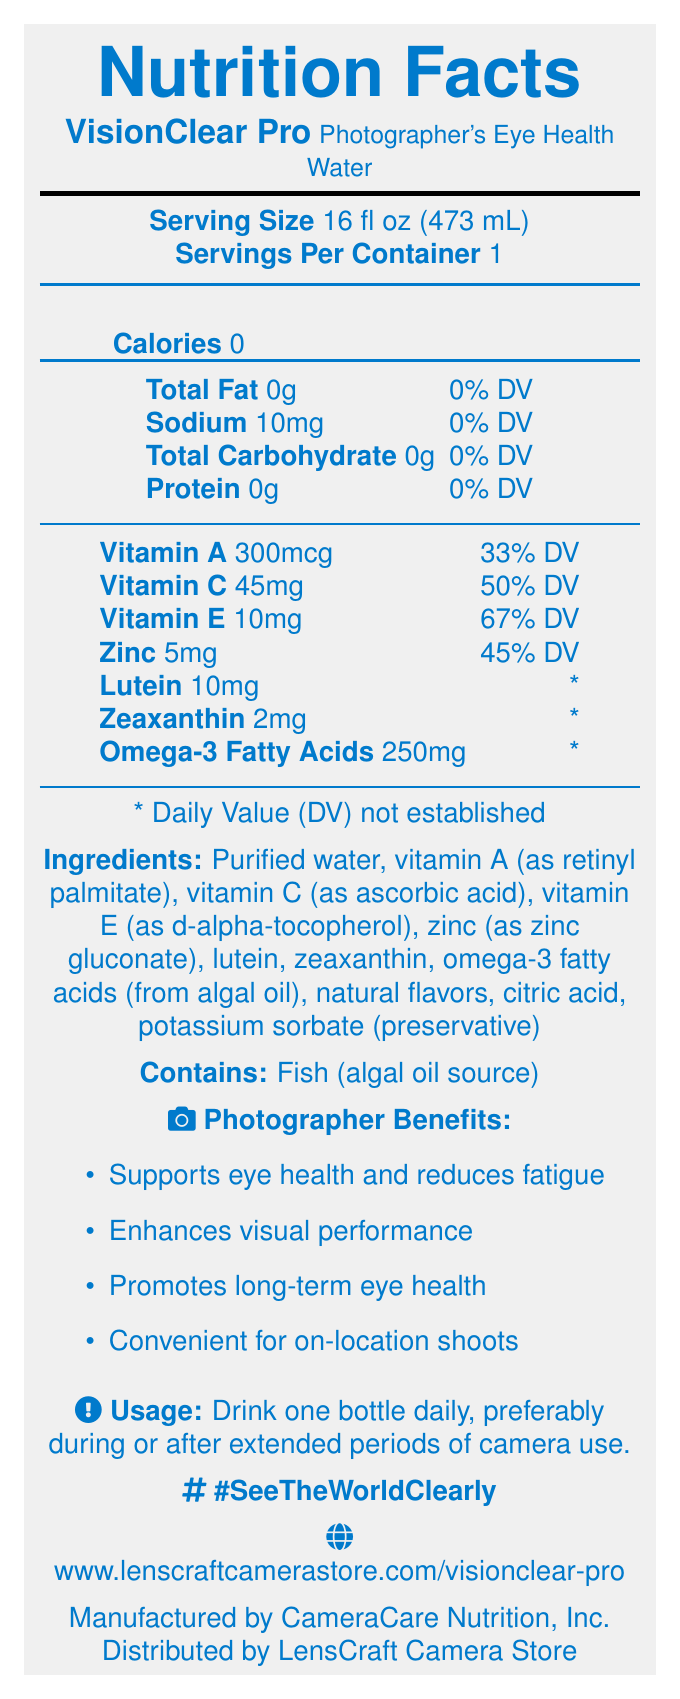what is the serving size for VisionClear Pro? The serving size is listed as "16 fl oz (473 mL)" in the document.
Answer: 16 fl oz (473 mL) how many servings per container are there? The document states there is 1 serving per container.
Answer: 1 how many calories are in one serving of VisionClear Pro? The document lists 0 calories under the nutrition facts.
Answer: 0 what percentage of the daily value does Vitamin A provide? The document states that Vitamin A provides 33% of the daily value.
Answer: 33% which manufacturer produces VisionClear Pro? The manufacturer listed is CameraCare Nutrition, Inc.
Answer: CameraCare Nutrition, Inc. Which of the following nutrients is not listed in the Nutrition Facts? A. Vitamin B12 B. Zinc C. Vitamin E D. Lutein Vitamin B12 is not listed in the Nutrition Facts, whereas Zinc, Vitamin E, and Lutein are included.
Answer: A What is the main ingredient in VisionClear Pro? A. Purified water B. Vitamin A C. Omega-3 Fatty Acids D. Citric Acid The first and primary ingredient listed is purified water.
Answer: A True or False: VisionClear Pro contains an ingredient derived from fish. The allergen information specifies that the product contains fish (algal oil source).
Answer: True Summarize the main idea of the VisionClear Pro document. The summary includes details on the product’s purpose (supporting eye health for photographers), key nutrients, manufacturer and distributor, and its health benefits.
Answer: VisionClear Pro is a vitamin-enriched bottled water designed to support eye health for photographers. It contains essential nutrients like Vitamin A, C, and E, as well as lutein, zeaxanthin, and omega-3 fatty acids. The drink is calorie-free and aims to reduce eye strain and enhance visual performance. It is manufactured by CameraCare Nutrition, Inc. and distributed by LensCraft Camera Store. how much sodium is in a serving of VisionClear Pro? The document indicates that there are 10mg of sodium per serving.
Answer: 10mg how should VisionClear Pro be stored after opening? The storage instructions specify to refrigerate after opening.
Answer: Refrigerate after opening what is the campaign hashtag for VisionClear Pro? The document lists the campaign hashtag as #SeeTheWorldClearly.
Answer: #SeeTheWorldClearly what benefits does VisionClear Pro claim to provide for photographers? The document claims it supports eye health, reduces fatigue, enhances performance, promotes long-term health, and is convenient during shoots.
Answer: Supports eye health, reduces eye strain, enhances visual performance, promotes long-term eye health, convenient hydration solution for on-location shoots what is the daily value percentage for Vitamin C? The document lists Vitamin C providing 50% of the daily value.
Answer: 50% how much omega-3 fatty acids does VisionClear Pro contain? The document lists 250mg of omega-3 fatty acids.
Answer: 250mg how often should VisionClear Pro be consumed for best results? The usage instructions recommend drinking one bottle daily.
Answer: Drink one bottle daily which distributor is responsible for distributing VisionClear Pro? The distributor is listed as LensCraft Camera Store.
Answer: LensCraft Camera Store what are the natural flavors used in VisionClear Pro? The document states "natural flavors" but does not specify what they are exactly.
Answer: Cannot be determined 